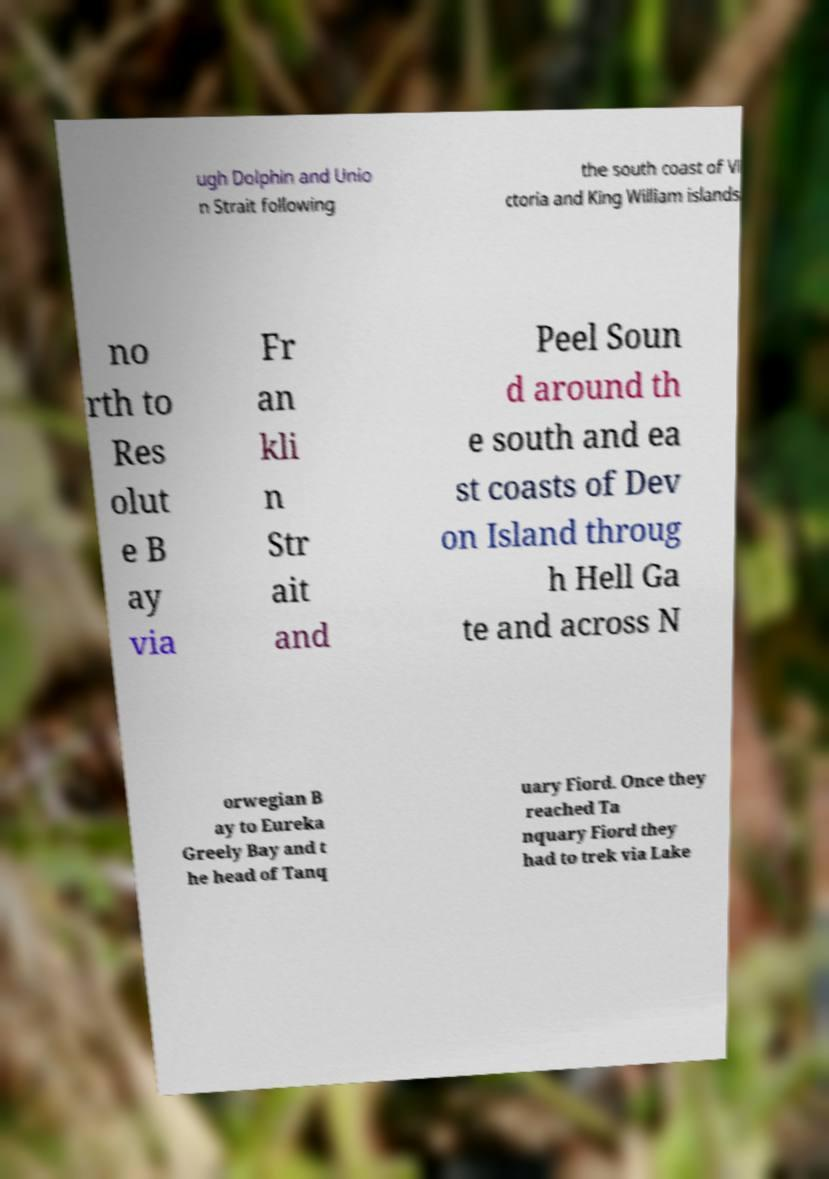There's text embedded in this image that I need extracted. Can you transcribe it verbatim? ugh Dolphin and Unio n Strait following the south coast of Vi ctoria and King William islands no rth to Res olut e B ay via Fr an kli n Str ait and Peel Soun d around th e south and ea st coasts of Dev on Island throug h Hell Ga te and across N orwegian B ay to Eureka Greely Bay and t he head of Tanq uary Fiord. Once they reached Ta nquary Fiord they had to trek via Lake 